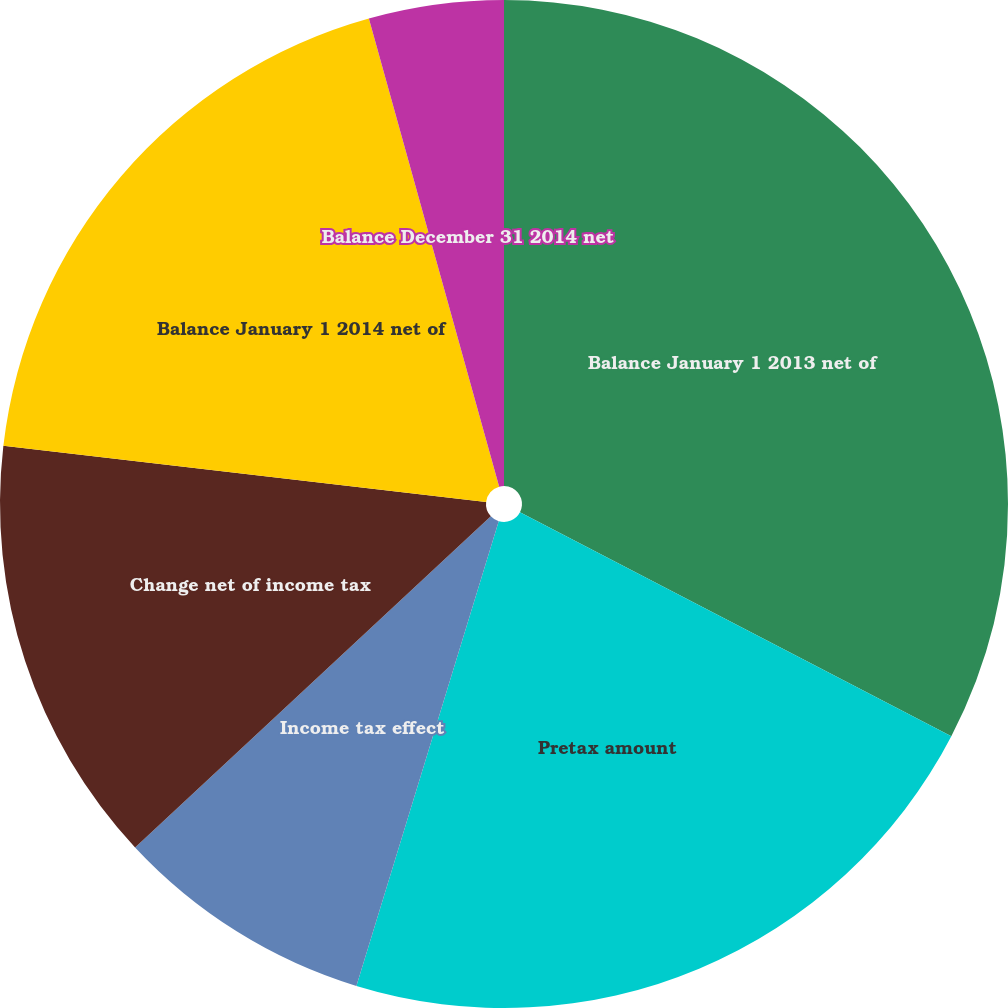Convert chart to OTSL. <chart><loc_0><loc_0><loc_500><loc_500><pie_chart><fcel>Balance January 1 2013 net of<fcel>Pretax amount<fcel>Income tax effect<fcel>Change net of income tax<fcel>Balance January 1 2014 net of<fcel>Balance December 31 2014 net<nl><fcel>32.62%<fcel>22.11%<fcel>8.34%<fcel>13.77%<fcel>18.84%<fcel>4.32%<nl></chart> 